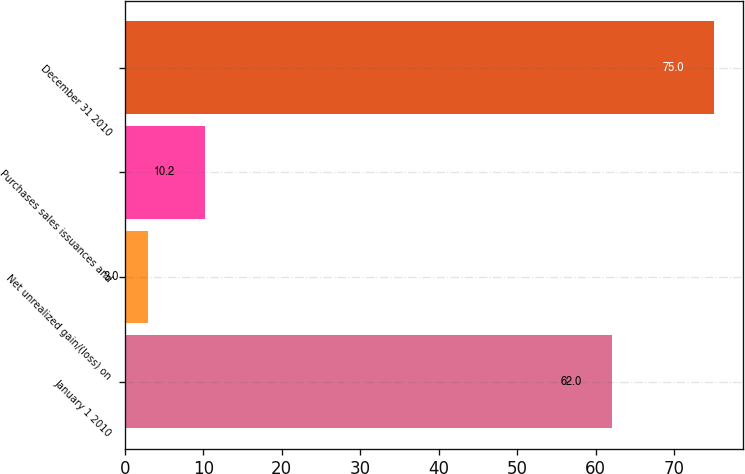Convert chart. <chart><loc_0><loc_0><loc_500><loc_500><bar_chart><fcel>January 1 2010<fcel>Net unrealized gain/(loss) on<fcel>Purchases sales issuances and<fcel>December 31 2010<nl><fcel>62<fcel>3<fcel>10.2<fcel>75<nl></chart> 